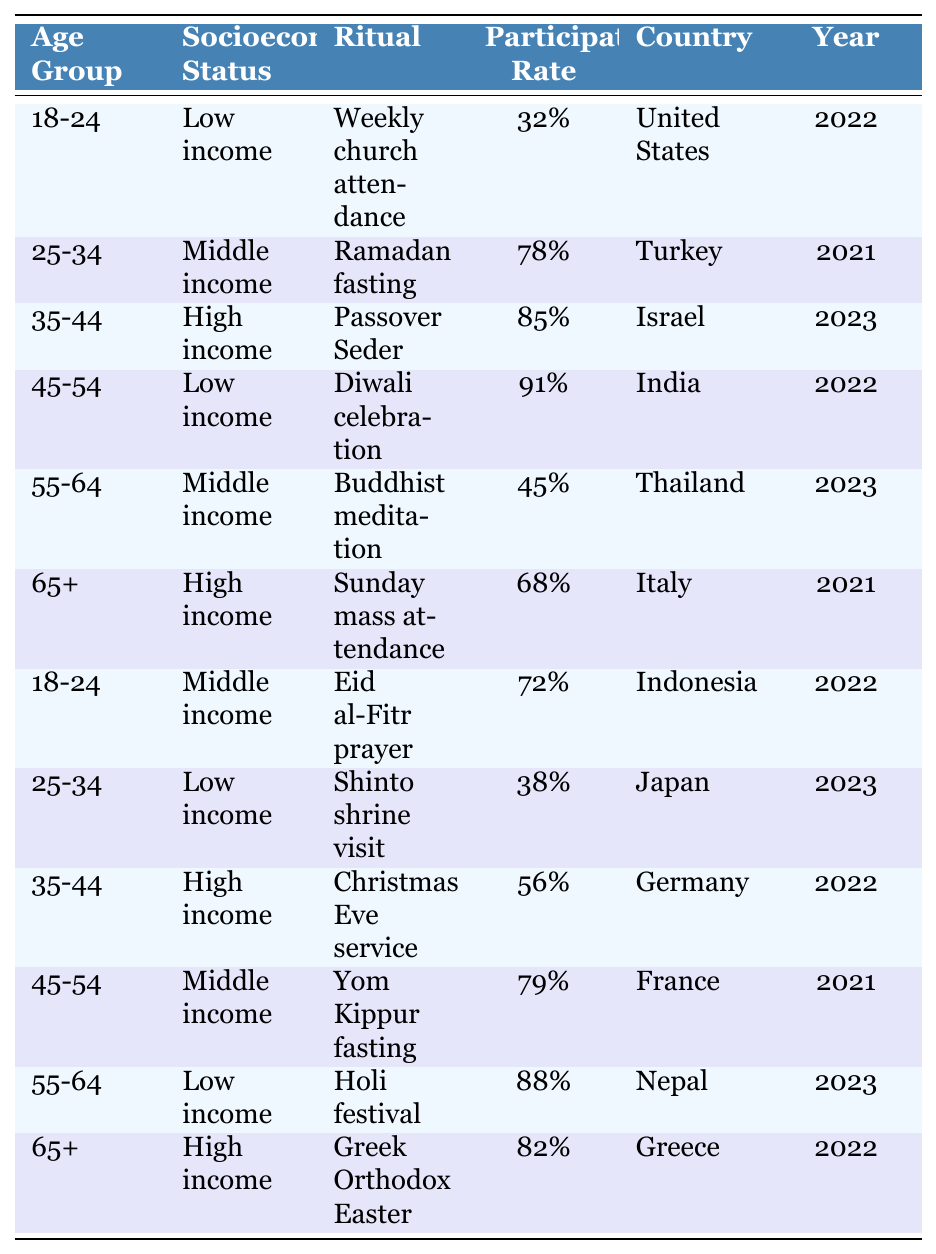What is the participation rate for the 45-54 age group with low income? Looking at the table, the entry for the 45-54 age group with low income shows a participation rate of 91%.
Answer: 91% Which socioeconomic status has the highest participation rate in religious rituals for the 35-44 age group? The table reveals that the high-income group in the 35-44 age group has a participation rate of 85%, which is the highest compared to other income levels in that age group.
Answer: High income What is the average participation rate for the low income demographic across all age groups? The participation rates for low-income groups are 32%, 91%, 38%, and 88%. Adding them yields 32 + 91 + 38 + 88 = 249. There are 4 entries, so the average is 249 / 4 = 62.25%.
Answer: 62.25% True or False: The participation rate in ritual for the 25-34 age group with low income exceeds that of the 18-24 age group with low income. The 25-34 age group with low income has a participation rate of 38% while the 18-24 age group with low income has 32%. Since 38% is greater than 32%, the statement is true.
Answer: True What is the difference in participation rates between the 55-64 age group with low income and the 65+ age group with high income? The 55-64 age group with low income has a participation rate of 88% and the 65+ age group with high income has a rate of 82%. The difference is calculated as 88% - 82% = 6%.
Answer: 6% What participation rates are there for the 18-24 age group across different socioeconomic statuses? The table indicates that for the 18-24 age group, there are two entry points: low income at 32% and middle income at 72%.
Answer: 32% and 72% Which country has the highest participation rate among the 45-54 age group and what is that rate? The entry for the 45-54 age group in India shows a participation rate of 91%, which is the highest for this age group.
Answer: India, 91% What is the total participation rate for rituals among the 65+ age group across different socioeconomic statuses? The 65+ age group has two entries: high income with 68% and another high income with 82%. Adding these gives 68 + 82 = 150%. The total participation rate across both entries is thus 150%.
Answer: 150% For the 35-44 age group, which ritual has the lowest participation rate based on socioeconomic status? The entries show that the 35-44 age group with high income has a participation rate of 85%, and another entry for the same group with high income (Christmas Eve service) is 56%. Since 56% is lower, this is the lowest participation rate for that age group regarding socioeconomic status.
Answer: Christmas Eve service, 56% Is there an age group with high income that participates less frequently in rituals compared to other age groups? Looking at the table, there is no age group with high income that has a lower participation rate than the 25-34 age group with low income at 38%. All high-income groups have higher rates than this.
Answer: Yes, there are no lower rates 